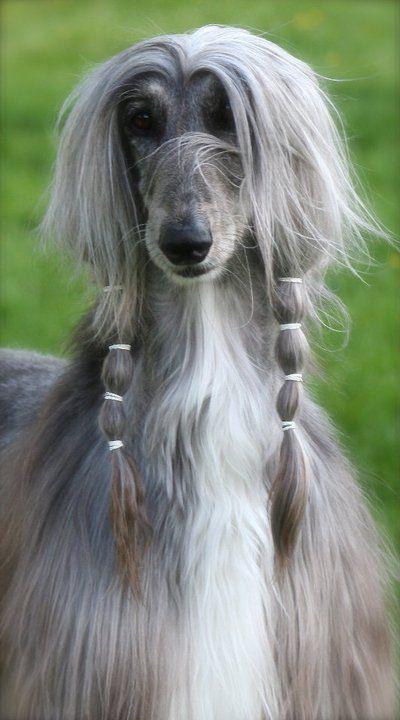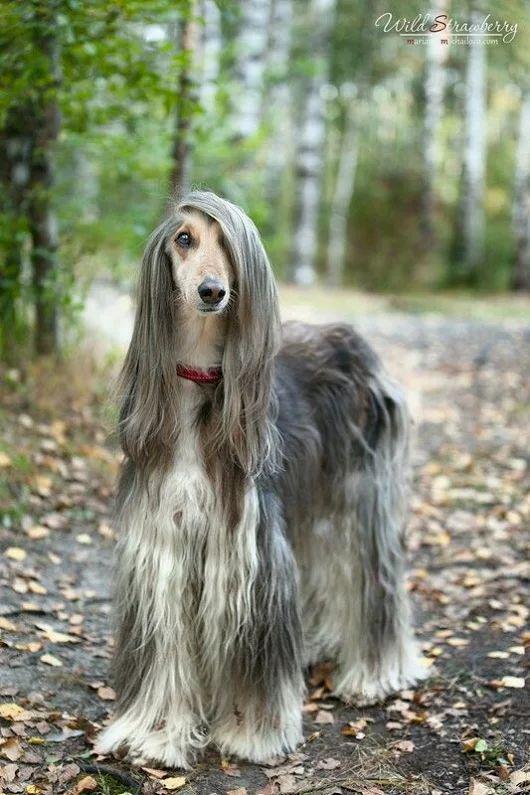The first image is the image on the left, the second image is the image on the right. Considering the images on both sides, is "One image shows a hound with windswept hair on its head." valid? Answer yes or no. No. 